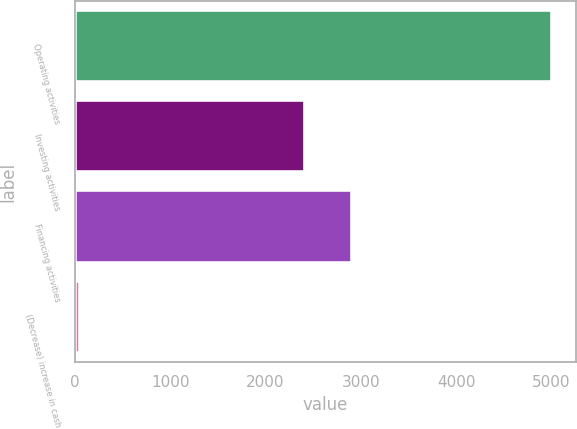Convert chart to OTSL. <chart><loc_0><loc_0><loc_500><loc_500><bar_chart><fcel>Operating activities<fcel>Investing activities<fcel>Financing activities<fcel>(Decrease) increase in cash<nl><fcel>5009<fcel>2414<fcel>2909.6<fcel>53<nl></chart> 